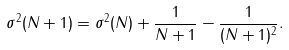<formula> <loc_0><loc_0><loc_500><loc_500>\sigma ^ { 2 } ( N + 1 ) = \sigma ^ { 2 } ( N ) + \frac { 1 } { N + 1 } - \frac { 1 } { ( N + 1 ) ^ { 2 } } .</formula> 